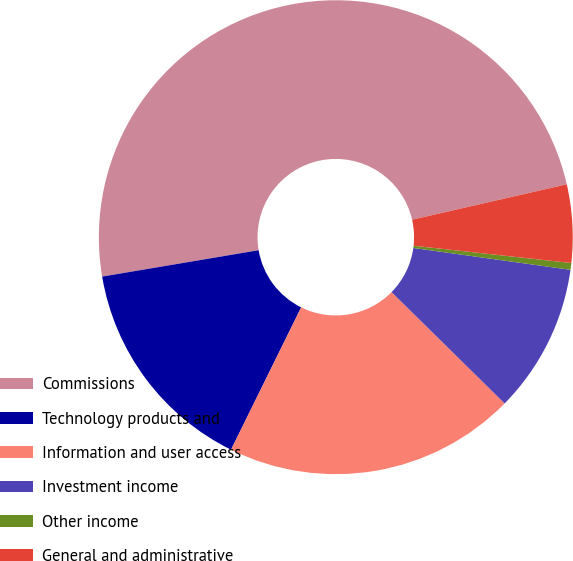Convert chart to OTSL. <chart><loc_0><loc_0><loc_500><loc_500><pie_chart><fcel>Commissions<fcel>Technology products and<fcel>Information and user access<fcel>Investment income<fcel>Other income<fcel>General and administrative<nl><fcel>49.08%<fcel>15.05%<fcel>19.91%<fcel>10.18%<fcel>0.46%<fcel>5.32%<nl></chart> 